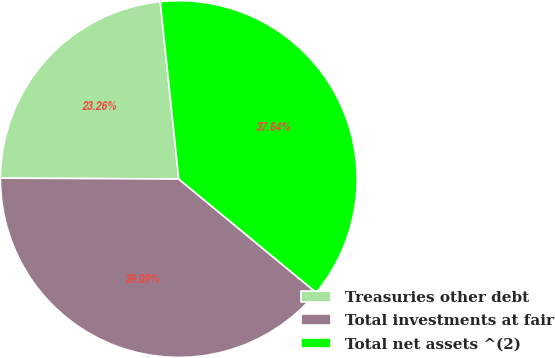Convert chart to OTSL. <chart><loc_0><loc_0><loc_500><loc_500><pie_chart><fcel>Treasuries other debt<fcel>Total investments at fair<fcel>Total net assets ^(2)<nl><fcel>23.26%<fcel>39.09%<fcel>37.64%<nl></chart> 